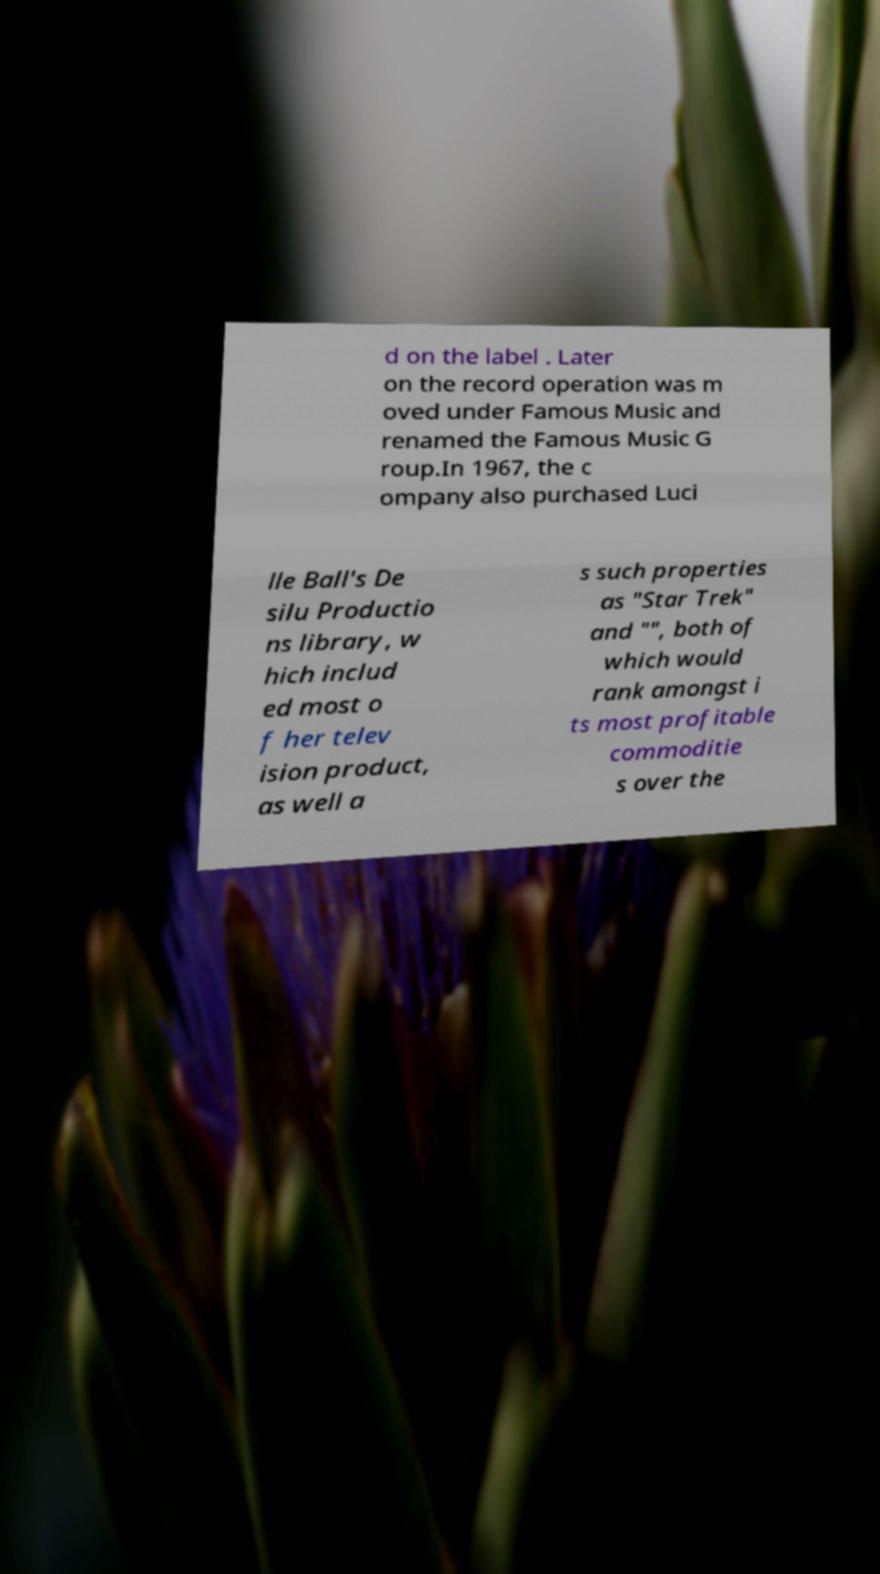I need the written content from this picture converted into text. Can you do that? d on the label . Later on the record operation was m oved under Famous Music and renamed the Famous Music G roup.In 1967, the c ompany also purchased Luci lle Ball's De silu Productio ns library, w hich includ ed most o f her telev ision product, as well a s such properties as "Star Trek" and "", both of which would rank amongst i ts most profitable commoditie s over the 